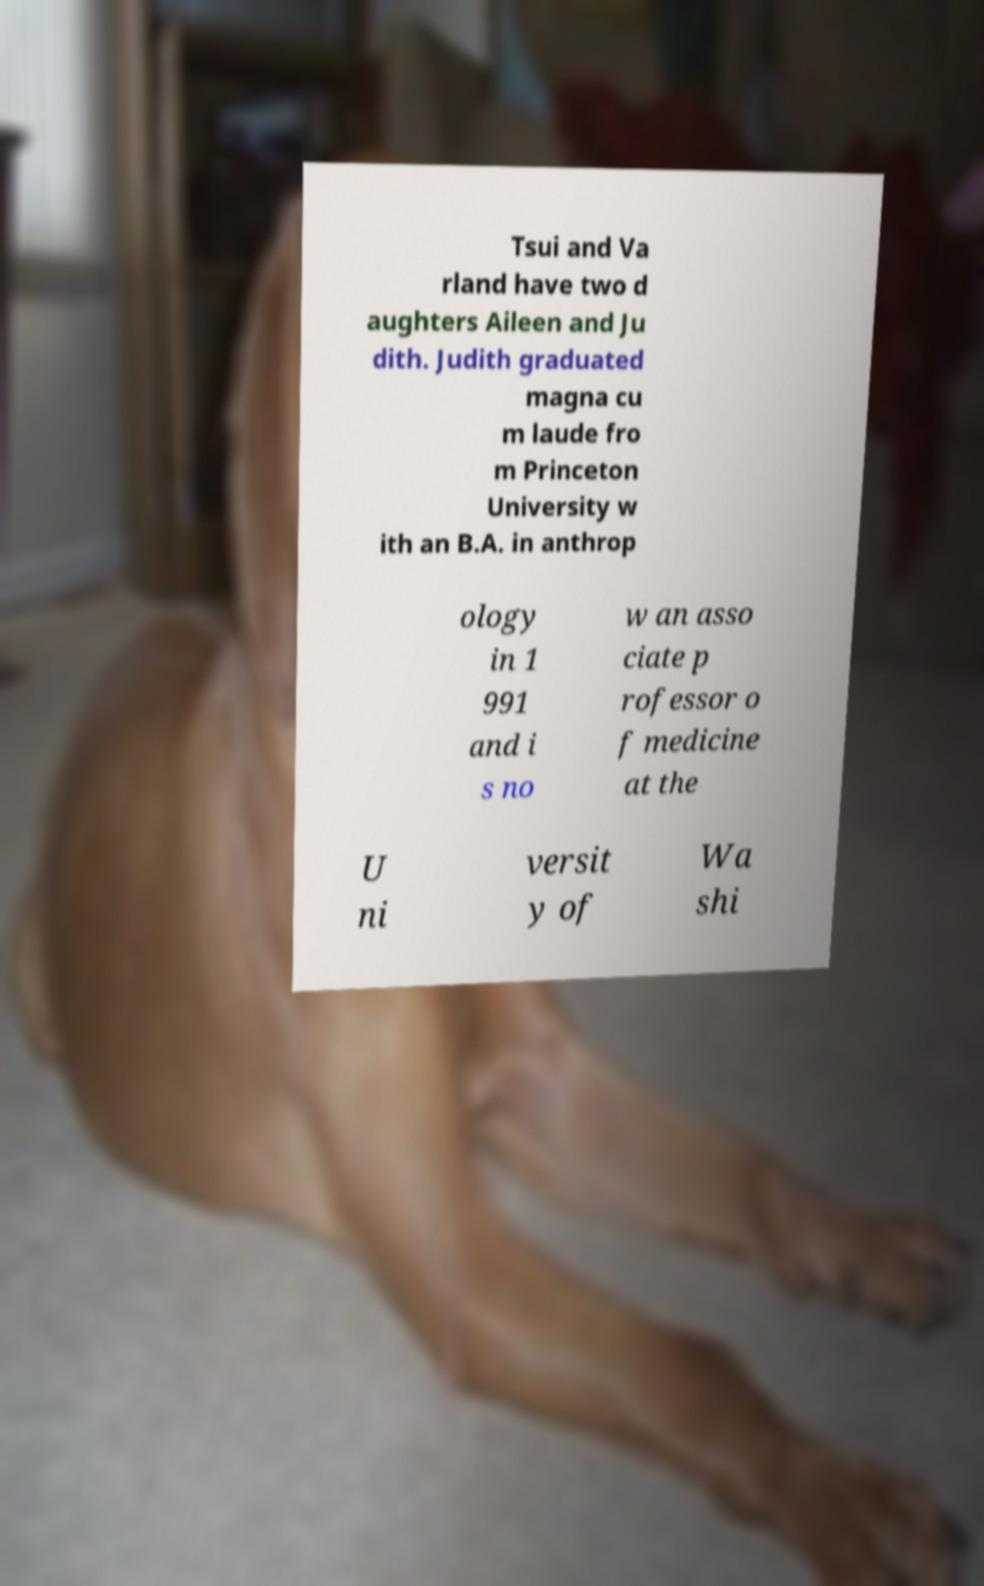There's text embedded in this image that I need extracted. Can you transcribe it verbatim? Tsui and Va rland have two d aughters Aileen and Ju dith. Judith graduated magna cu m laude fro m Princeton University w ith an B.A. in anthrop ology in 1 991 and i s no w an asso ciate p rofessor o f medicine at the U ni versit y of Wa shi 